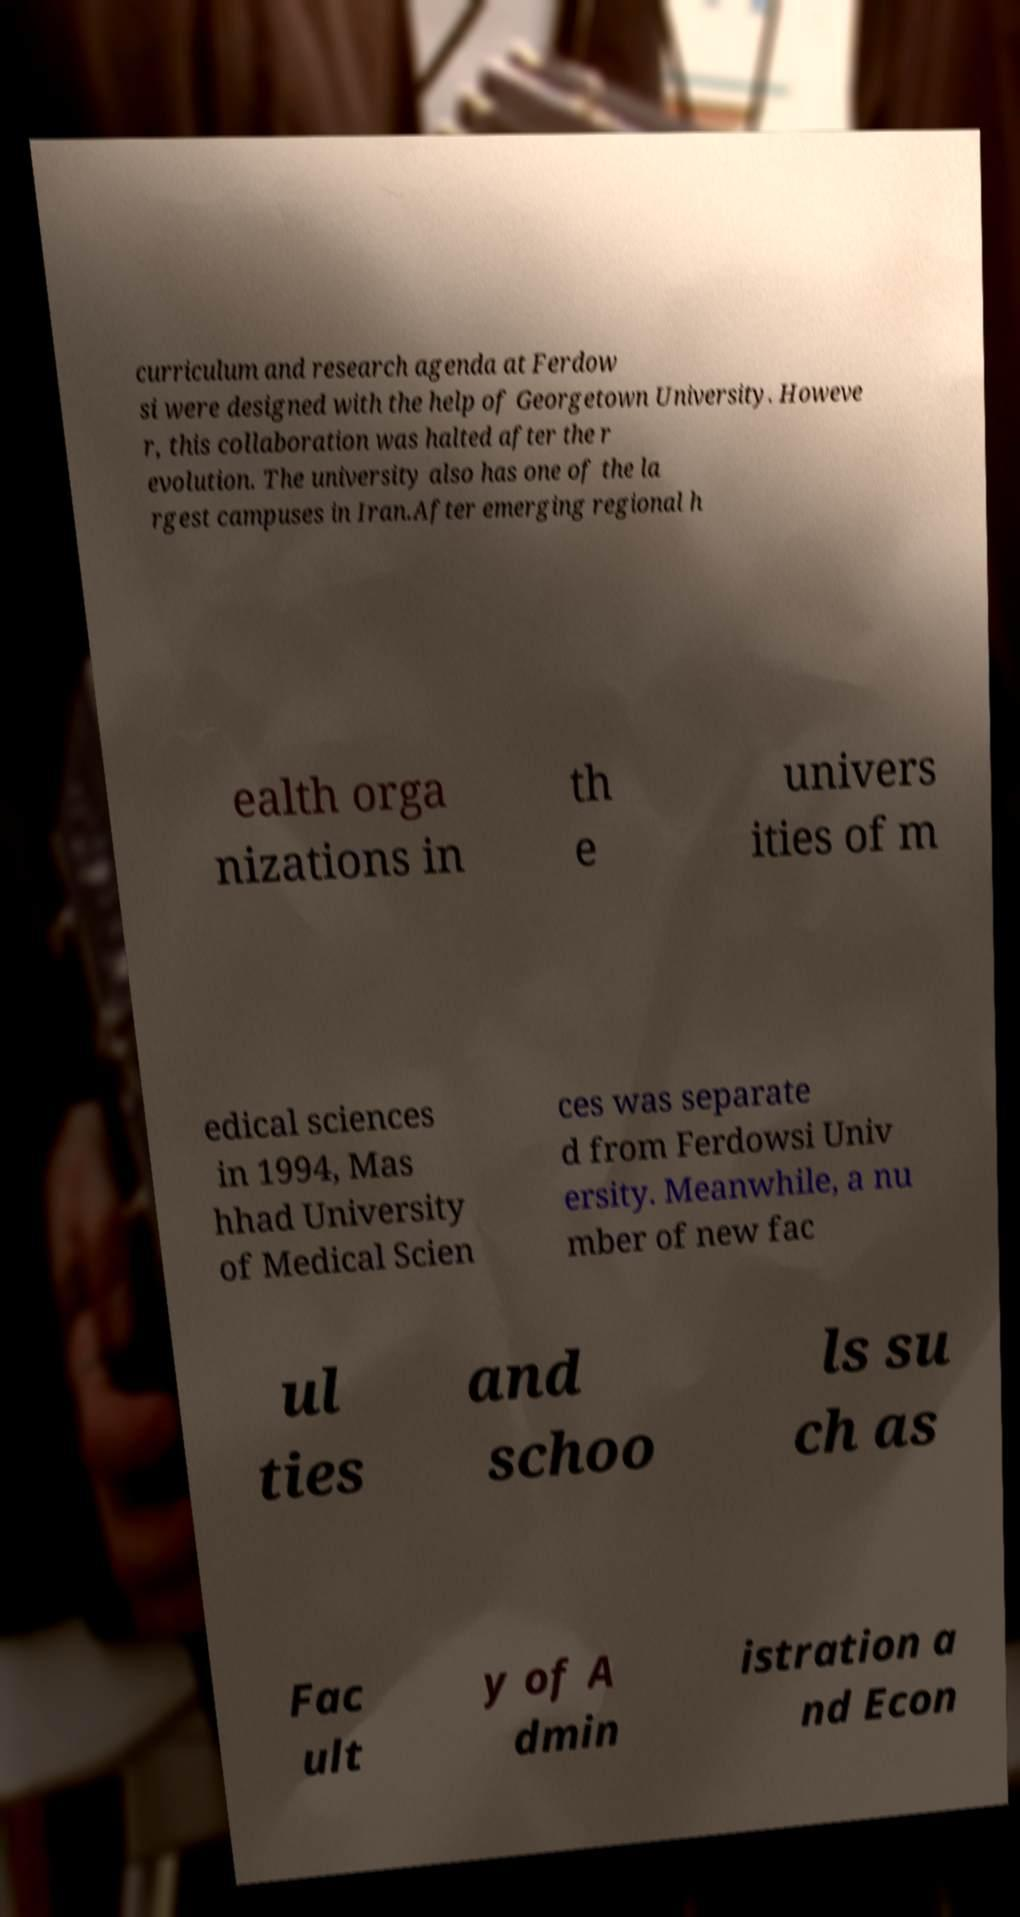I need the written content from this picture converted into text. Can you do that? curriculum and research agenda at Ferdow si were designed with the help of Georgetown University. Howeve r, this collaboration was halted after the r evolution. The university also has one of the la rgest campuses in Iran.After emerging regional h ealth orga nizations in th e univers ities of m edical sciences in 1994, Mas hhad University of Medical Scien ces was separate d from Ferdowsi Univ ersity. Meanwhile, a nu mber of new fac ul ties and schoo ls su ch as Fac ult y of A dmin istration a nd Econ 